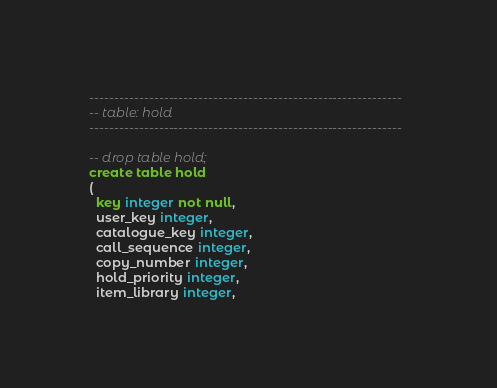Convert code to text. <code><loc_0><loc_0><loc_500><loc_500><_SQL_>---------------------------------------------------------------
-- table: hold
---------------------------------------------------------------

-- drop table hold;
create table hold
(
  key integer not null,
  user_key integer,
  catalogue_key integer,
  call_sequence integer,
  copy_number integer,
  hold_priority integer,
  item_library integer,</code> 